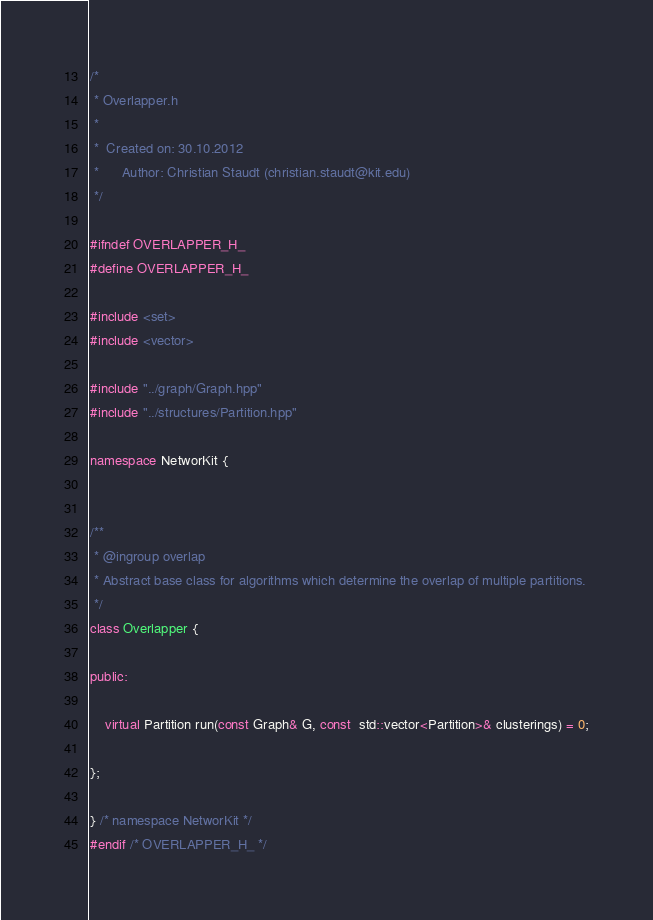Convert code to text. <code><loc_0><loc_0><loc_500><loc_500><_C++_>/*
 * Overlapper.h
 *
 *  Created on: 30.10.2012
 *      Author: Christian Staudt (christian.staudt@kit.edu)
 */

#ifndef OVERLAPPER_H_
#define OVERLAPPER_H_

#include <set>
#include <vector>

#include "../graph/Graph.hpp"
#include "../structures/Partition.hpp"

namespace NetworKit {


/**
 * @ingroup overlap
 * Abstract base class for algorithms which determine the overlap of multiple partitions.
 */
class Overlapper {

public:

	virtual Partition run(const Graph& G, const  std::vector<Partition>& clusterings) = 0;

};

} /* namespace NetworKit */
#endif /* OVERLAPPER_H_ */
</code> 